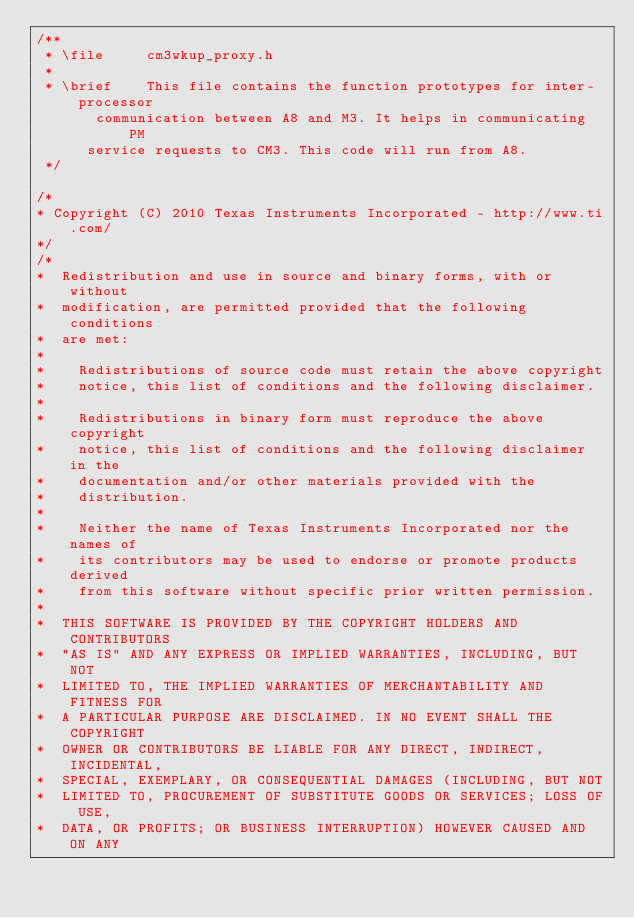<code> <loc_0><loc_0><loc_500><loc_500><_C_>/**
 * \file     cm3wkup_proxy.h
 *
 * \brief    This file contains the function prototypes for inter-processor
			 communication between A8 and M3. It helps in communicating PM
			service requests to CM3. This code will run from A8.
 */

/*
* Copyright (C) 2010 Texas Instruments Incorporated - http://www.ti.com/
*/
/*
*  Redistribution and use in source and binary forms, with or without
*  modification, are permitted provided that the following conditions
*  are met:
*
*    Redistributions of source code must retain the above copyright
*    notice, this list of conditions and the following disclaimer.
*
*    Redistributions in binary form must reproduce the above copyright
*    notice, this list of conditions and the following disclaimer in the
*    documentation and/or other materials provided with the
*    distribution.
*
*    Neither the name of Texas Instruments Incorporated nor the names of
*    its contributors may be used to endorse or promote products derived
*    from this software without specific prior written permission.
*
*  THIS SOFTWARE IS PROVIDED BY THE COPYRIGHT HOLDERS AND CONTRIBUTORS
*  "AS IS" AND ANY EXPRESS OR IMPLIED WARRANTIES, INCLUDING, BUT NOT
*  LIMITED TO, THE IMPLIED WARRANTIES OF MERCHANTABILITY AND FITNESS FOR
*  A PARTICULAR PURPOSE ARE DISCLAIMED. IN NO EVENT SHALL THE COPYRIGHT
*  OWNER OR CONTRIBUTORS BE LIABLE FOR ANY DIRECT, INDIRECT, INCIDENTAL,
*  SPECIAL, EXEMPLARY, OR CONSEQUENTIAL DAMAGES (INCLUDING, BUT NOT
*  LIMITED TO, PROCUREMENT OF SUBSTITUTE GOODS OR SERVICES; LOSS OF USE,
*  DATA, OR PROFITS; OR BUSINESS INTERRUPTION) HOWEVER CAUSED AND ON ANY</code> 